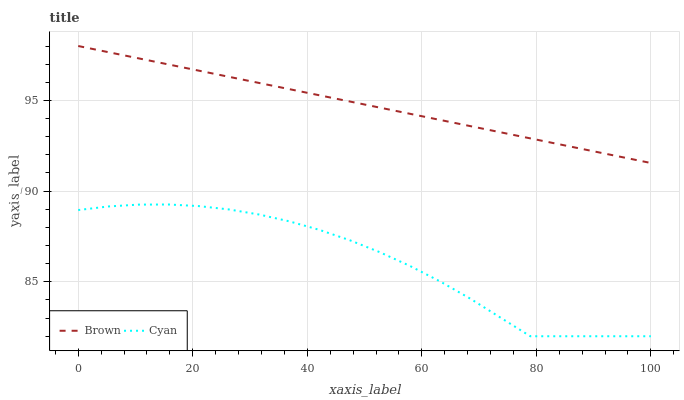Does Cyan have the maximum area under the curve?
Answer yes or no. No. Is Cyan the smoothest?
Answer yes or no. No. Does Cyan have the highest value?
Answer yes or no. No. Is Cyan less than Brown?
Answer yes or no. Yes. Is Brown greater than Cyan?
Answer yes or no. Yes. Does Cyan intersect Brown?
Answer yes or no. No. 